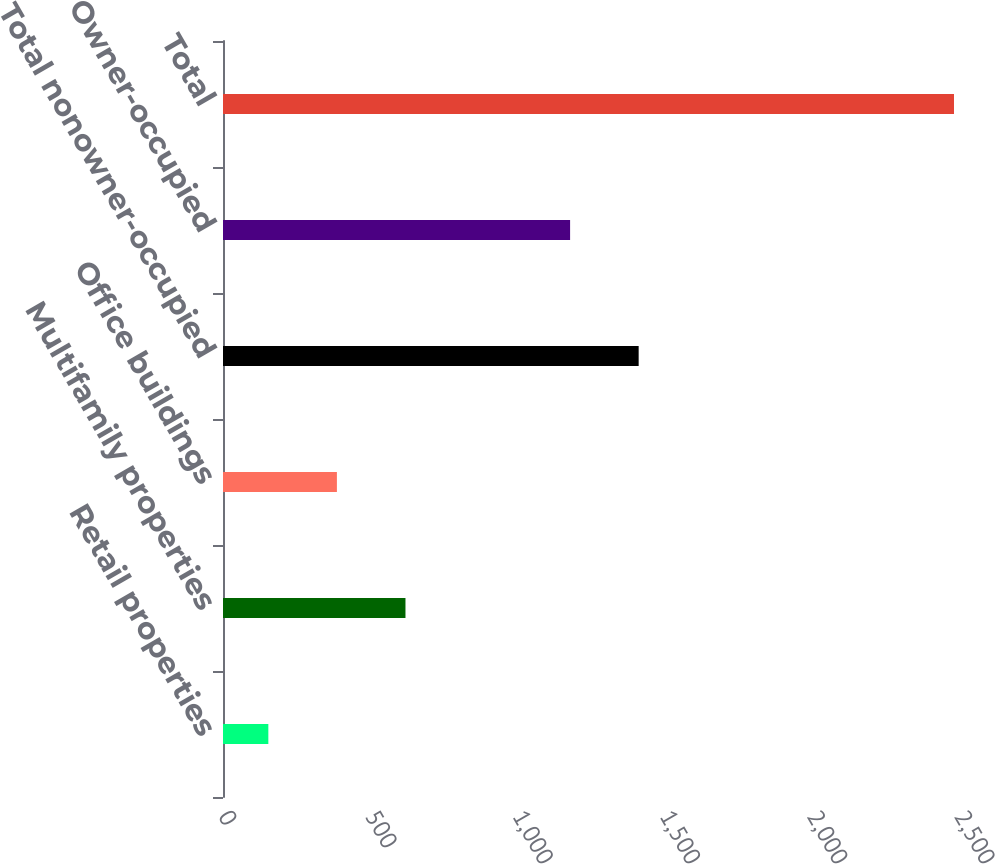Convert chart. <chart><loc_0><loc_0><loc_500><loc_500><bar_chart><fcel>Retail properties<fcel>Multifamily properties<fcel>Office buildings<fcel>Total nonowner-occupied<fcel>Owner-occupied<fcel>Total<nl><fcel>154<fcel>619.8<fcel>386.9<fcel>1411.9<fcel>1179<fcel>2483<nl></chart> 